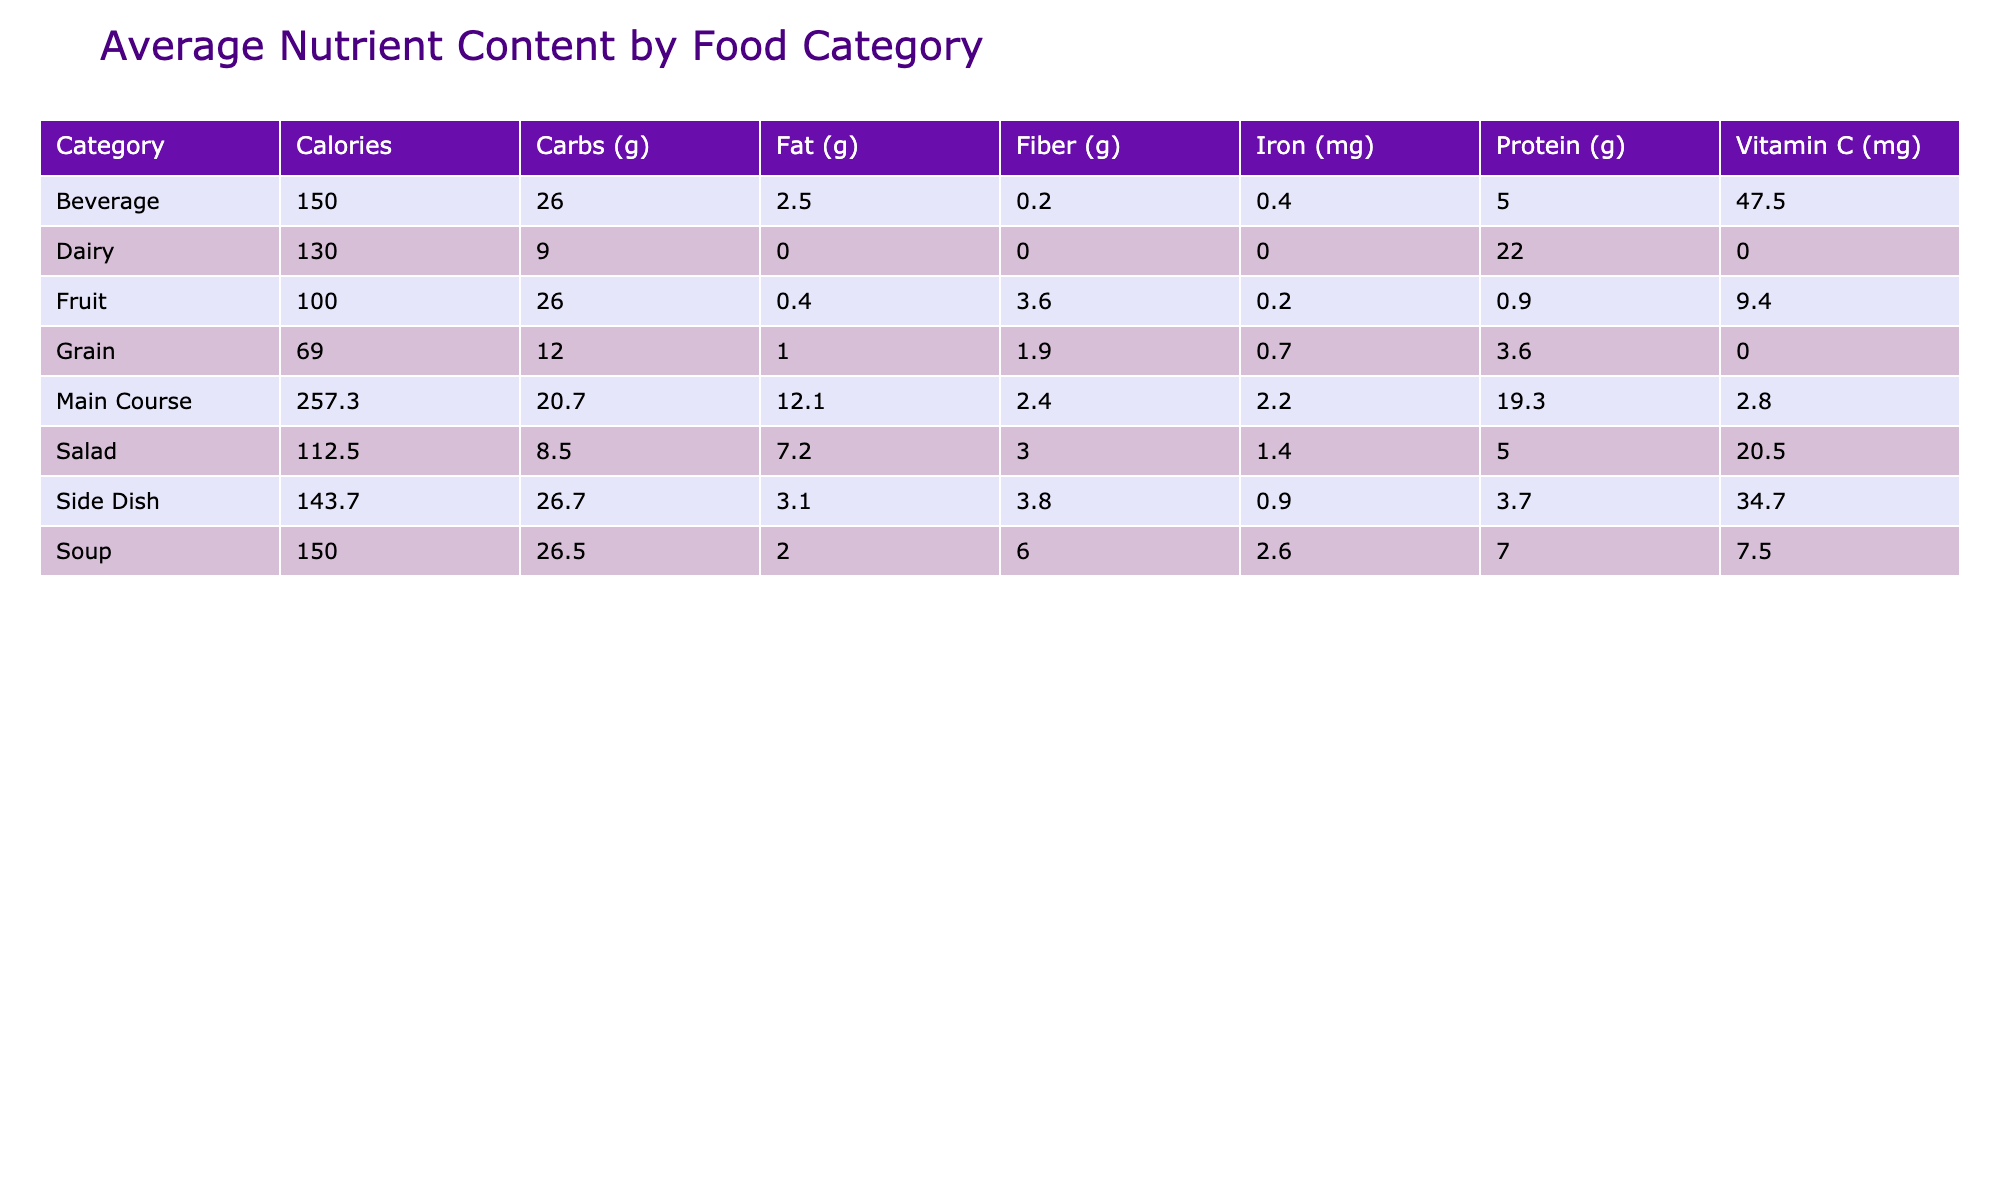What is the average calorie content in the Main Course category? To find the average calorie content in the Main Course category, I look at the calorie values of Grilled Chicken Breast, Cheeseburger, Tuna Sandwich, Spinach and Feta Wrap, and Quinoa Bowl. Their calorie values are 165, 350, 290, 290, and 280, respectively. I sum these values to get (165 + 350 + 290 + 290 + 280) = 1375. There are 5 items, so I divide 1375 by 5, which gives me an average of 275.
Answer: 275 Which food item in the Salad category has the highest Vitamin C content? I check the Vitamin C values for the items in the Salad category: Caesar Salad has 3 mg, Steamed Broccoli has 5 mg, and Mixed Green Salad has 3 mg. The highest value among these is from Steamed Broccoli, which has 5 mg of Vitamin C.
Answer: 5 mg Is the average fat content in Side Dishes greater than 6 grams? I examine the fat content for the Side Dish category: Steamed Broccoli has 0.5 g, Brown Rice has 1.8 g, Sweet Potato Fries has 7 g. The average is calculated as (0.5 + 1.8 + 7) = 9.3 g, which is divided by 3, yielding an average of 3.1 g. This is less than 6 grams.
Answer: No What is the difference in protein content between the highest and lowest protein food items in the Dairy and Fruit categories? I look for protein content in the Dairy category: Greek Yogurt has 22 g. In the Fruit category, I find that Apple has 0.5 g and Banana has 1.3 g, making Banana the highest. The difference between the highest (Greek Yogurt) and lowest (Apple) is 22 g - 0.5 g = 21.5 g.
Answer: 21.5 g Which category has the lowest average fiber content? I check the fiber values for each category. For Main Course, the average fiber is calculated as (0 + 0 + 3 + 3 + 1) = 7, divided by 5 gives 1.4 g. The Salad category has an average of 2.3 g from Caesar Salad and Mixed Green Salad. The Soup category averages 2.5 g from Vegetable and Lentil Soup. The Side Dish averages about 2.5 g. Therefore, the category with the lowest average fiber is the Main Course.
Answer: Main Course 